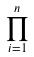<formula> <loc_0><loc_0><loc_500><loc_500>\prod _ { i = 1 } ^ { n }</formula> 